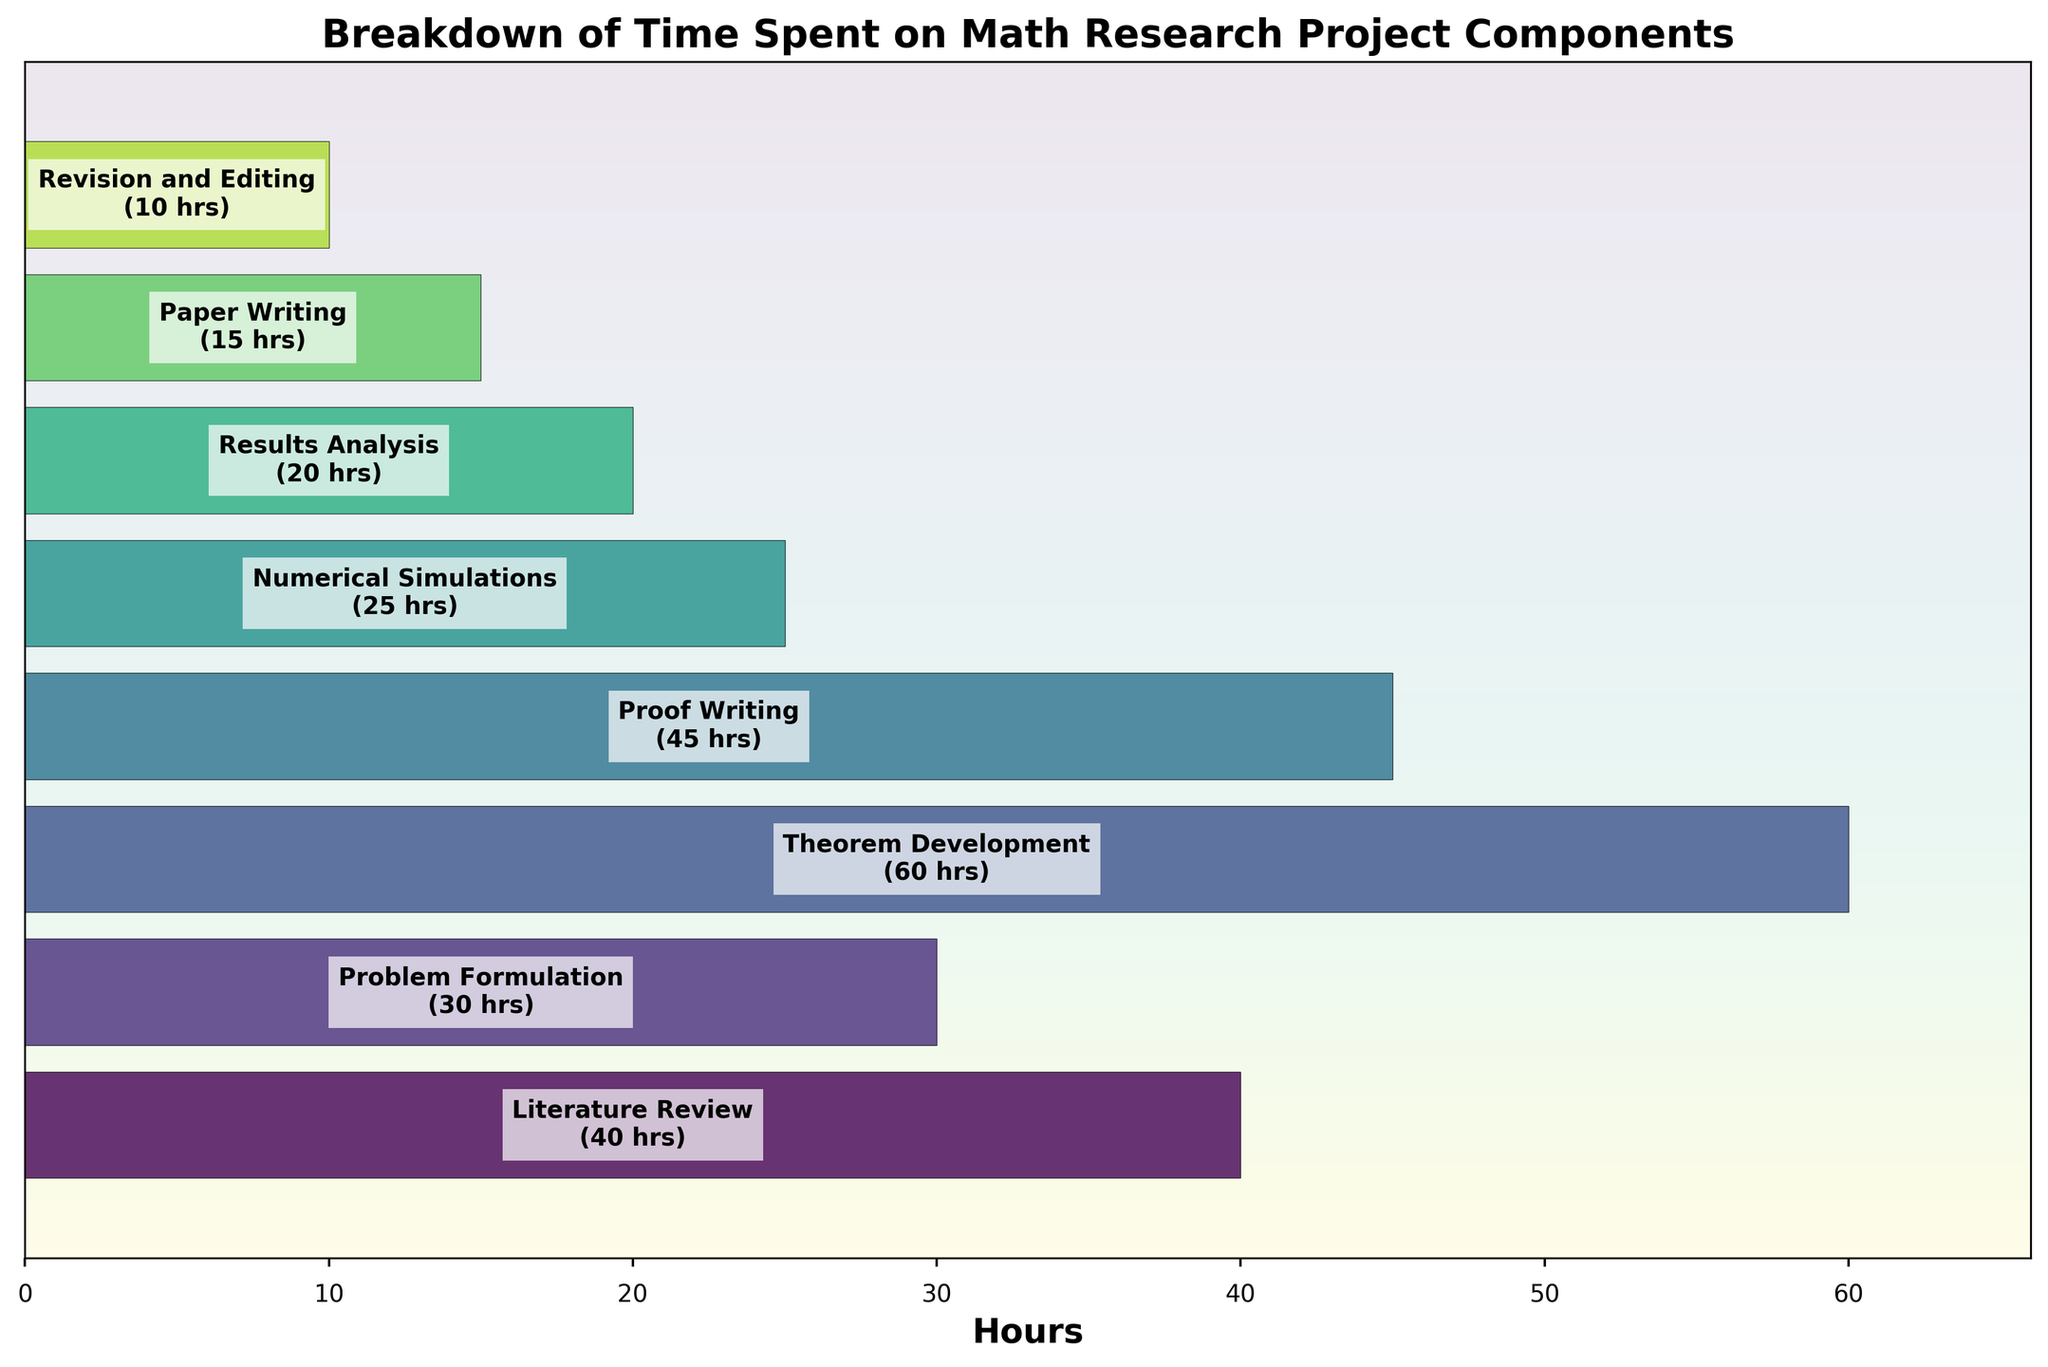How much time is spent on Theorem Development? The figure indicates the number of hours next to each stage, where Theorem Development is labeled with 60 hours.
Answer: 60 hours What is the shortest amount of time spent on any stage? To find the shortest time spent, we look at all the hours in the figure and notice that Revision and Editing has the smallest number of hours, which is 10.
Answer: 10 hours What is the total amount of time spent on the research project? Sum all the hours shown in the figure: 40 + 30 + 60 + 45 + 25 + 20 + 15 + 10 = 245 hours.
Answer: 245 hours How much more time is spent on Proof Writing compared to Paper Writing? Proof Writing takes 45 hours and Paper Writing takes 15 hours, so the difference is 45 - 15 = 30 hours.
Answer: 30 hours Which stage takes more time: Literature Review or Results Analysis? The figure shows Literature Review takes 40 hours and Results Analysis takes 20 hours. Since 40 is more than 20, Literature Review takes more time.
Answer: Literature Review By how many hours does Theorem Development exceed Numerical Simulations? Theorem Development takes 60 hours, and Numerical Simulations take 25 hours, so the difference is 60 - 25 = 35 hours.
Answer: 35 hours Which stage occupies the least and the most amount of time in this research project? From the figure, the stage that occupies the highest amount of time is Theorem Development with 60 hours, and the stage with the least amount of time is Revision and Editing with 10 hours.
Answer: Theorem Development; Revision and Editing What percentage of the total project time is spent on Literature Review? First, find the total project time which is 245 hours. Then, calculate the percentage of Literature Review time: (40 / 245) * 100 = 16.33%.
Answer: 16.33% Which stage has almost half the time allocation of Theorem Development? Theorem Development takes 60 hours. Half of it is 30 hours. Problem Formulation takes exactly 30 hours, fitting the criteria.
Answer: Problem Formulation Sort the stages in descending order based on the time spent. Reviewing the hours for each stage: Theorem Development (60), Proof Writing (45), Literature Review (40), Problem Formulation (30), Numerical Simulations (25), Results Analysis (20), Paper Writing (15), Revision and Editing (10). Thus, the order is: Theorem Development, Proof Writing, Literature Review, Problem Formulation, Numerical Simulations, Results Analysis, Paper Writing, Revision and Editing.
Answer: Theorem Development, Proof Writing, Literature Review, Problem Formulation, Numerical Simulations, Results Analysis, Paper Writing, Revision and Editing 